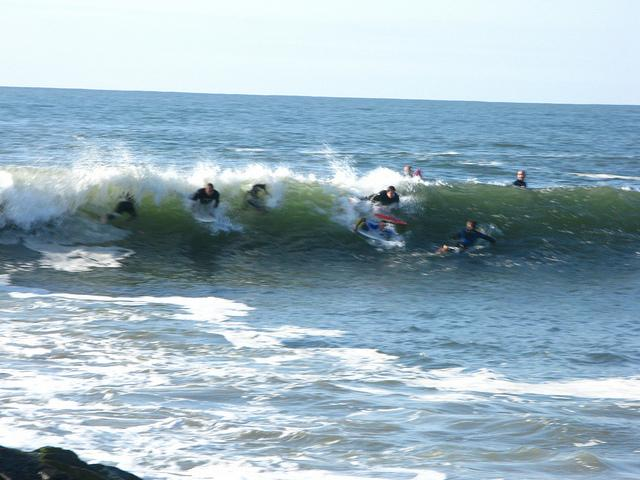What are the surfers in a push up position attempting to do?

Choices:
A) exercise
B) stand
C) roll
D) dive stand 